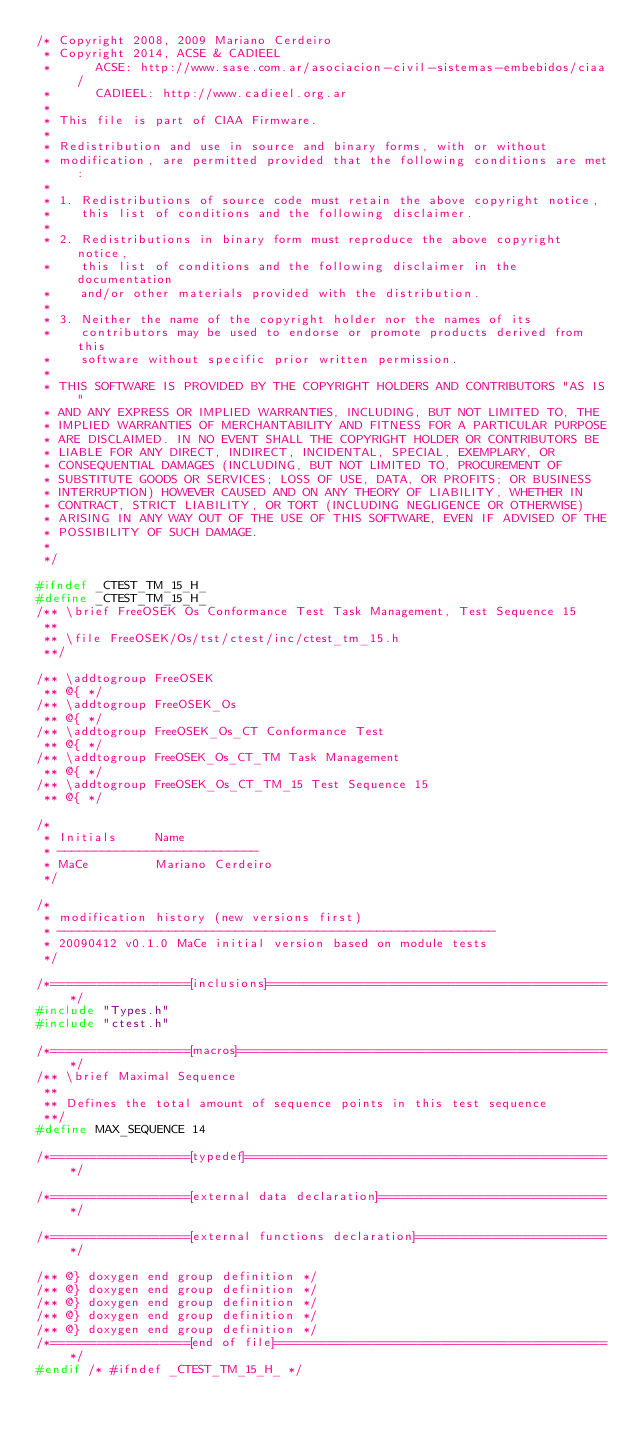Convert code to text. <code><loc_0><loc_0><loc_500><loc_500><_C_>/* Copyright 2008, 2009 Mariano Cerdeiro
 * Copyright 2014, ACSE & CADIEEL
 *      ACSE: http://www.sase.com.ar/asociacion-civil-sistemas-embebidos/ciaa/
 *      CADIEEL: http://www.cadieel.org.ar
 *
 * This file is part of CIAA Firmware.
 *
 * Redistribution and use in source and binary forms, with or without
 * modification, are permitted provided that the following conditions are met:
 *
 * 1. Redistributions of source code must retain the above copyright notice,
 *    this list of conditions and the following disclaimer.
 *
 * 2. Redistributions in binary form must reproduce the above copyright notice,
 *    this list of conditions and the following disclaimer in the documentation
 *    and/or other materials provided with the distribution.
 *
 * 3. Neither the name of the copyright holder nor the names of its
 *    contributors may be used to endorse or promote products derived from this
 *    software without specific prior written permission.
 *
 * THIS SOFTWARE IS PROVIDED BY THE COPYRIGHT HOLDERS AND CONTRIBUTORS "AS IS"
 * AND ANY EXPRESS OR IMPLIED WARRANTIES, INCLUDING, BUT NOT LIMITED TO, THE
 * IMPLIED WARRANTIES OF MERCHANTABILITY AND FITNESS FOR A PARTICULAR PURPOSE
 * ARE DISCLAIMED. IN NO EVENT SHALL THE COPYRIGHT HOLDER OR CONTRIBUTORS BE
 * LIABLE FOR ANY DIRECT, INDIRECT, INCIDENTAL, SPECIAL, EXEMPLARY, OR
 * CONSEQUENTIAL DAMAGES (INCLUDING, BUT NOT LIMITED TO, PROCUREMENT OF
 * SUBSTITUTE GOODS OR SERVICES; LOSS OF USE, DATA, OR PROFITS; OR BUSINESS
 * INTERRUPTION) HOWEVER CAUSED AND ON ANY THEORY OF LIABILITY, WHETHER IN
 * CONTRACT, STRICT LIABILITY, OR TORT (INCLUDING NEGLIGENCE OR OTHERWISE)
 * ARISING IN ANY WAY OUT OF THE USE OF THIS SOFTWARE, EVEN IF ADVISED OF THE
 * POSSIBILITY OF SUCH DAMAGE.
 *
 */

#ifndef _CTEST_TM_15_H_
#define _CTEST_TM_15_H_
/** \brief FreeOSEK Os Conformance Test Task Management, Test Sequence 15
 **
 ** \file FreeOSEK/Os/tst/ctest/inc/ctest_tm_15.h
 **/

/** \addtogroup FreeOSEK
 ** @{ */
/** \addtogroup FreeOSEK_Os
 ** @{ */
/** \addtogroup FreeOSEK_Os_CT Conformance Test
 ** @{ */
/** \addtogroup FreeOSEK_Os_CT_TM Task Management
 ** @{ */
/** \addtogroup FreeOSEK_Os_CT_TM_15 Test Sequence 15
 ** @{ */

/*
 * Initials     Name
 * ---------------------------
 * MaCe         Mariano Cerdeiro
 */

/*
 * modification history (new versions first)
 * -----------------------------------------------------------
 * 20090412 v0.1.0 MaCe initial version based on module tests
 */

/*==================[inclusions]=============================================*/
#include "Types.h"
#include "ctest.h"

/*==================[macros]=================================================*/
/** \brief Maximal Sequence
 **
 ** Defines the total amount of sequence points in this test sequence
 **/
#define MAX_SEQUENCE 14

/*==================[typedef]================================================*/

/*==================[external data declaration]==============================*/

/*==================[external functions declaration]=========================*/

/** @} doxygen end group definition */
/** @} doxygen end group definition */
/** @} doxygen end group definition */
/** @} doxygen end group definition */
/** @} doxygen end group definition */
/*==================[end of file]============================================*/
#endif /* #ifndef _CTEST_TM_15_H_ */

</code> 